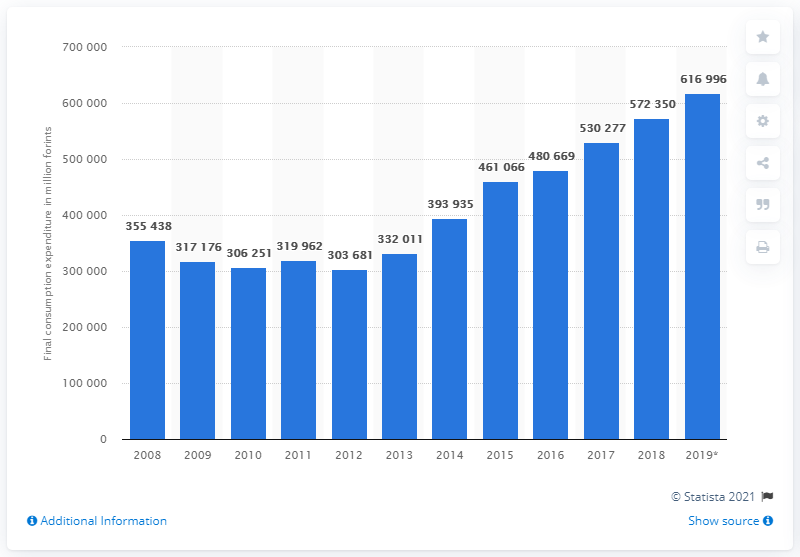Outline some significant characteristics in this image. In 2019, the Hungarian government spent 616,996 forints on clothing. 